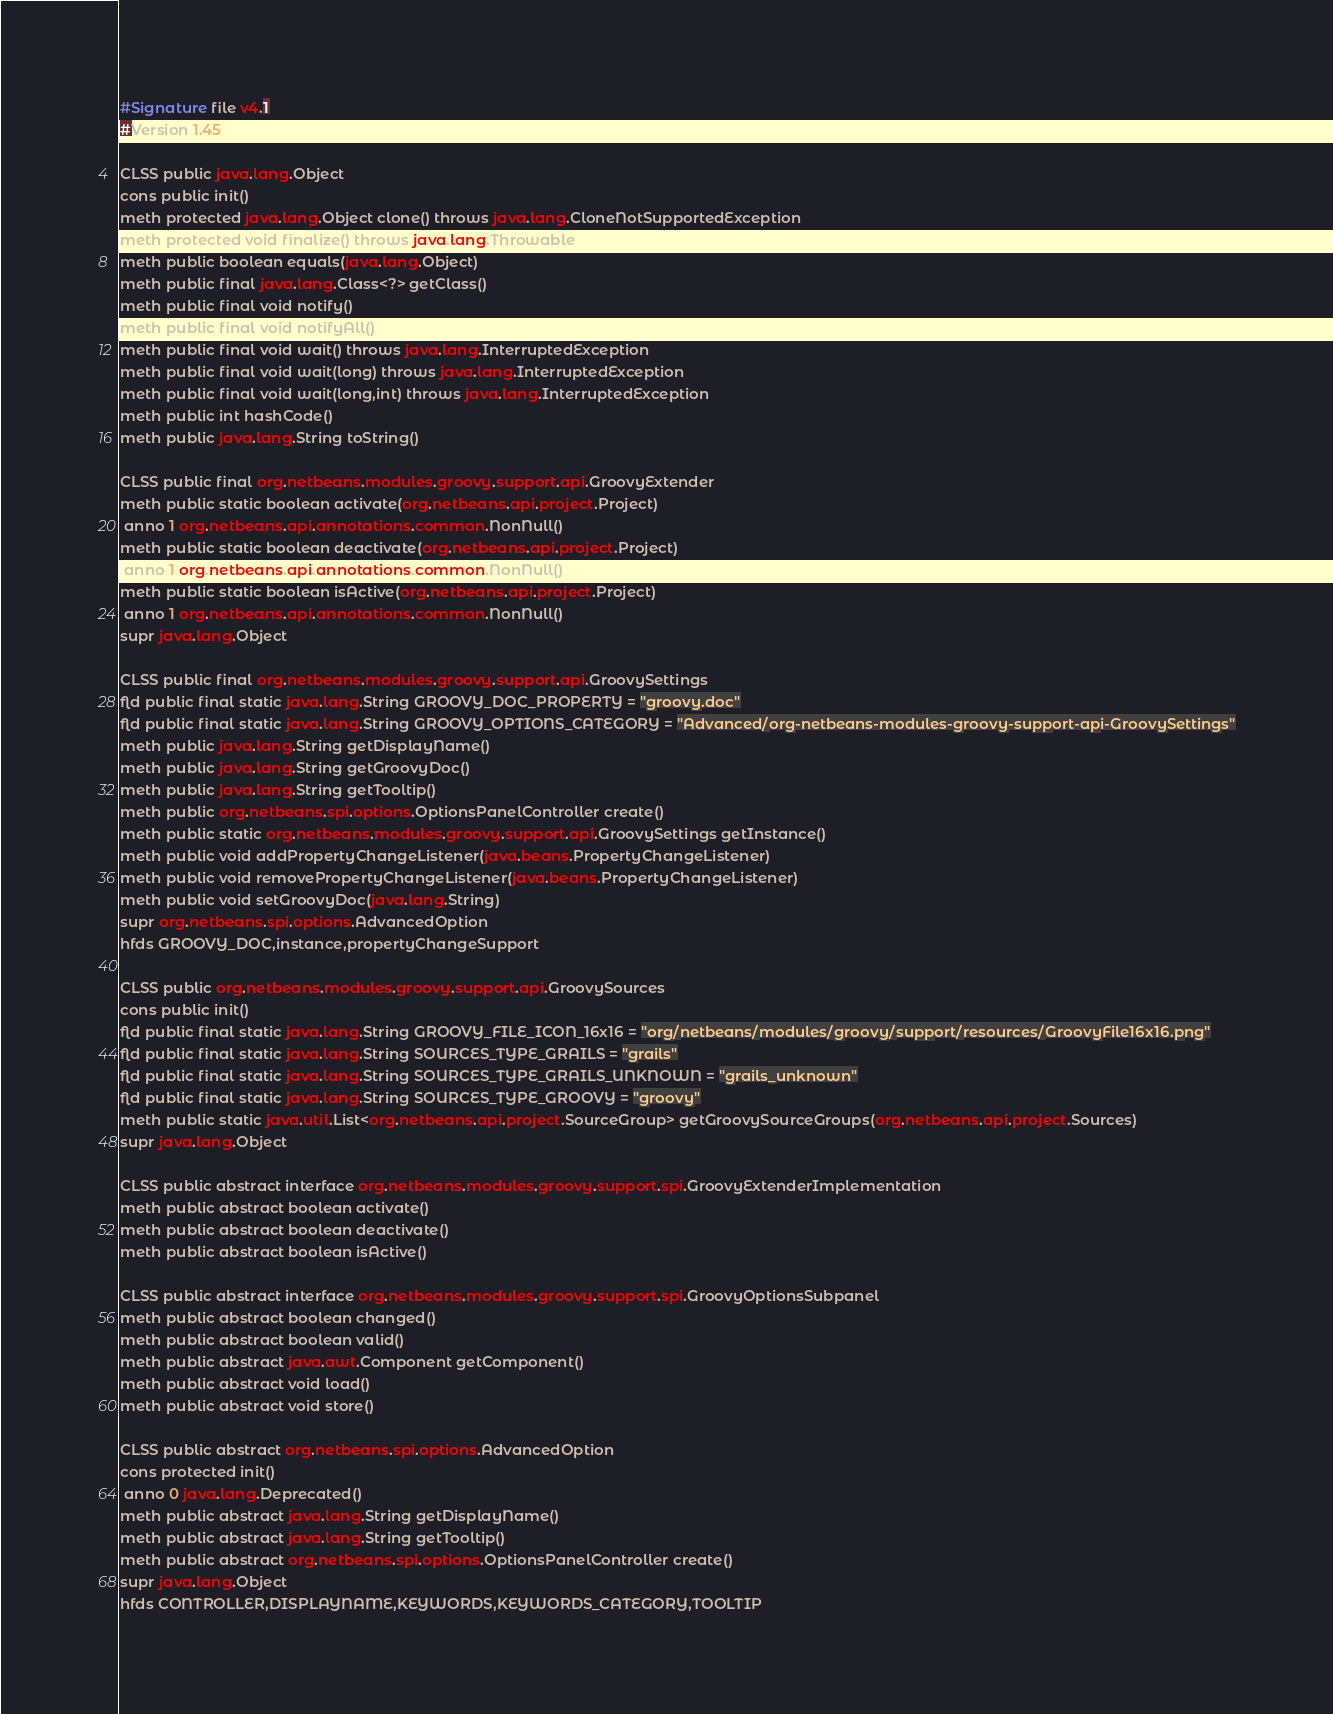<code> <loc_0><loc_0><loc_500><loc_500><_SML_>#Signature file v4.1
#Version 1.45

CLSS public java.lang.Object
cons public init()
meth protected java.lang.Object clone() throws java.lang.CloneNotSupportedException
meth protected void finalize() throws java.lang.Throwable
meth public boolean equals(java.lang.Object)
meth public final java.lang.Class<?> getClass()
meth public final void notify()
meth public final void notifyAll()
meth public final void wait() throws java.lang.InterruptedException
meth public final void wait(long) throws java.lang.InterruptedException
meth public final void wait(long,int) throws java.lang.InterruptedException
meth public int hashCode()
meth public java.lang.String toString()

CLSS public final org.netbeans.modules.groovy.support.api.GroovyExtender
meth public static boolean activate(org.netbeans.api.project.Project)
 anno 1 org.netbeans.api.annotations.common.NonNull()
meth public static boolean deactivate(org.netbeans.api.project.Project)
 anno 1 org.netbeans.api.annotations.common.NonNull()
meth public static boolean isActive(org.netbeans.api.project.Project)
 anno 1 org.netbeans.api.annotations.common.NonNull()
supr java.lang.Object

CLSS public final org.netbeans.modules.groovy.support.api.GroovySettings
fld public final static java.lang.String GROOVY_DOC_PROPERTY = "groovy.doc"
fld public final static java.lang.String GROOVY_OPTIONS_CATEGORY = "Advanced/org-netbeans-modules-groovy-support-api-GroovySettings"
meth public java.lang.String getDisplayName()
meth public java.lang.String getGroovyDoc()
meth public java.lang.String getTooltip()
meth public org.netbeans.spi.options.OptionsPanelController create()
meth public static org.netbeans.modules.groovy.support.api.GroovySettings getInstance()
meth public void addPropertyChangeListener(java.beans.PropertyChangeListener)
meth public void removePropertyChangeListener(java.beans.PropertyChangeListener)
meth public void setGroovyDoc(java.lang.String)
supr org.netbeans.spi.options.AdvancedOption
hfds GROOVY_DOC,instance,propertyChangeSupport

CLSS public org.netbeans.modules.groovy.support.api.GroovySources
cons public init()
fld public final static java.lang.String GROOVY_FILE_ICON_16x16 = "org/netbeans/modules/groovy/support/resources/GroovyFile16x16.png"
fld public final static java.lang.String SOURCES_TYPE_GRAILS = "grails"
fld public final static java.lang.String SOURCES_TYPE_GRAILS_UNKNOWN = "grails_unknown"
fld public final static java.lang.String SOURCES_TYPE_GROOVY = "groovy"
meth public static java.util.List<org.netbeans.api.project.SourceGroup> getGroovySourceGroups(org.netbeans.api.project.Sources)
supr java.lang.Object

CLSS public abstract interface org.netbeans.modules.groovy.support.spi.GroovyExtenderImplementation
meth public abstract boolean activate()
meth public abstract boolean deactivate()
meth public abstract boolean isActive()

CLSS public abstract interface org.netbeans.modules.groovy.support.spi.GroovyOptionsSubpanel
meth public abstract boolean changed()
meth public abstract boolean valid()
meth public abstract java.awt.Component getComponent()
meth public abstract void load()
meth public abstract void store()

CLSS public abstract org.netbeans.spi.options.AdvancedOption
cons protected init()
 anno 0 java.lang.Deprecated()
meth public abstract java.lang.String getDisplayName()
meth public abstract java.lang.String getTooltip()
meth public abstract org.netbeans.spi.options.OptionsPanelController create()
supr java.lang.Object
hfds CONTROLLER,DISPLAYNAME,KEYWORDS,KEYWORDS_CATEGORY,TOOLTIP

</code> 